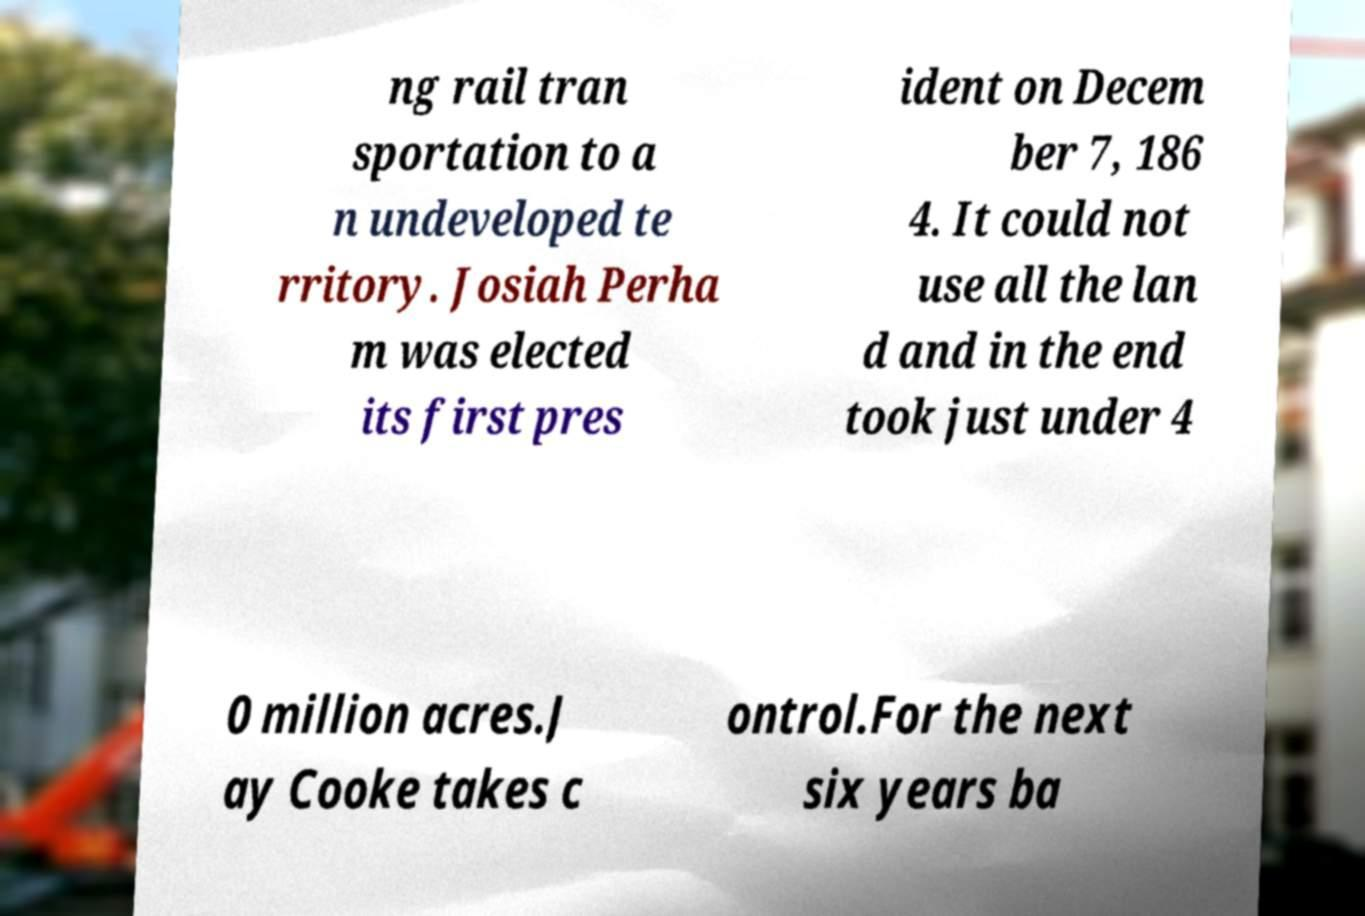There's text embedded in this image that I need extracted. Can you transcribe it verbatim? ng rail tran sportation to a n undeveloped te rritory. Josiah Perha m was elected its first pres ident on Decem ber 7, 186 4. It could not use all the lan d and in the end took just under 4 0 million acres.J ay Cooke takes c ontrol.For the next six years ba 